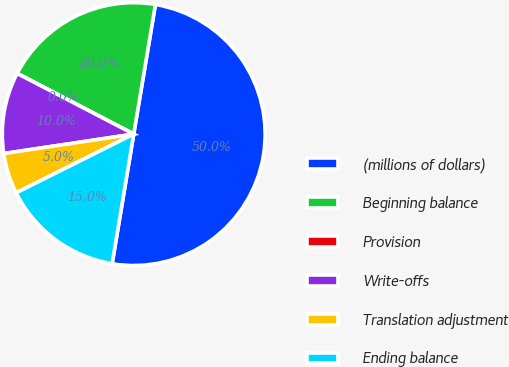Convert chart to OTSL. <chart><loc_0><loc_0><loc_500><loc_500><pie_chart><fcel>(millions of dollars)<fcel>Beginning balance<fcel>Provision<fcel>Write-offs<fcel>Translation adjustment<fcel>Ending balance<nl><fcel>49.99%<fcel>20.0%<fcel>0.01%<fcel>10.0%<fcel>5.01%<fcel>15.0%<nl></chart> 